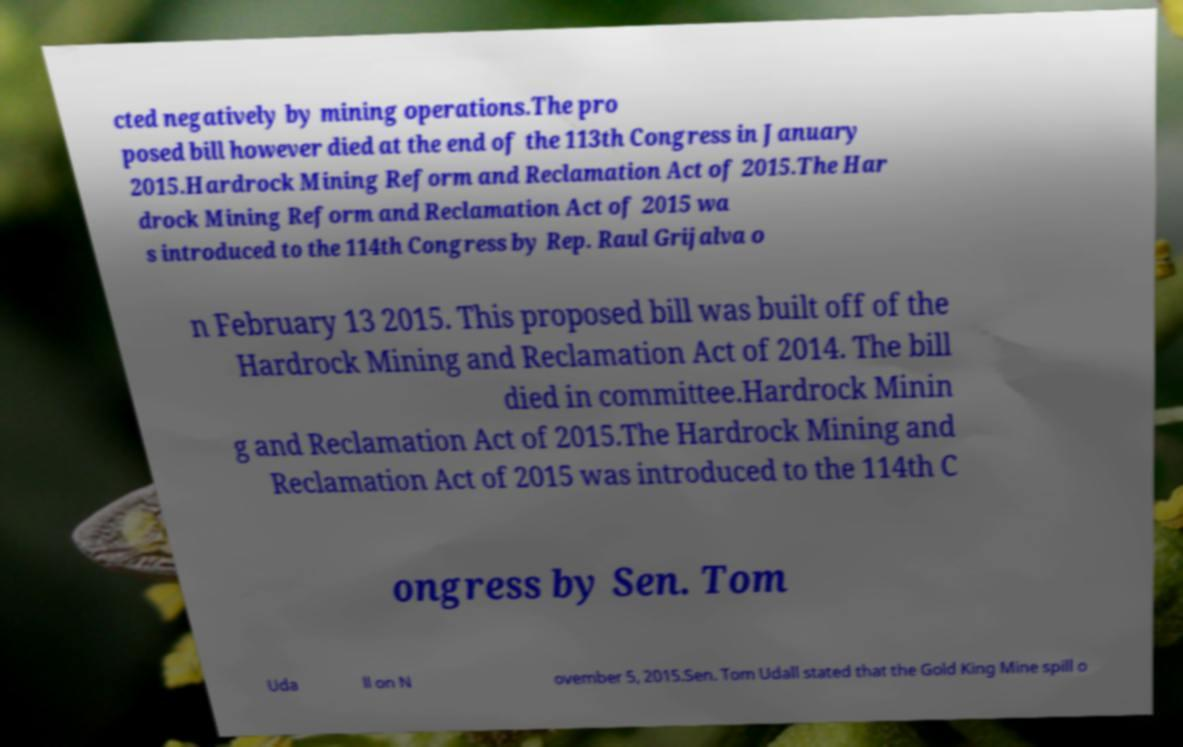For documentation purposes, I need the text within this image transcribed. Could you provide that? cted negatively by mining operations.The pro posed bill however died at the end of the 113th Congress in January 2015.Hardrock Mining Reform and Reclamation Act of 2015.The Har drock Mining Reform and Reclamation Act of 2015 wa s introduced to the 114th Congress by Rep. Raul Grijalva o n February 13 2015. This proposed bill was built off of the Hardrock Mining and Reclamation Act of 2014. The bill died in committee.Hardrock Minin g and Reclamation Act of 2015.The Hardrock Mining and Reclamation Act of 2015 was introduced to the 114th C ongress by Sen. Tom Uda ll on N ovember 5, 2015.Sen. Tom Udall stated that the Gold King Mine spill o 